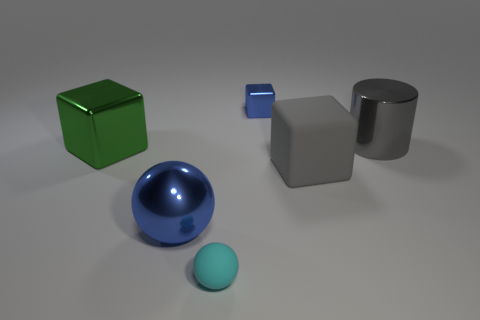Subtract all metallic blocks. How many blocks are left? 1 Add 1 big gray things. How many objects exist? 7 Subtract all cylinders. How many objects are left? 5 Subtract 0 cyan cylinders. How many objects are left? 6 Subtract all tiny rubber things. Subtract all gray blocks. How many objects are left? 4 Add 1 small cyan things. How many small cyan things are left? 2 Add 5 blue balls. How many blue balls exist? 6 